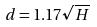<formula> <loc_0><loc_0><loc_500><loc_500>d = 1 . 1 7 \sqrt { H }</formula> 